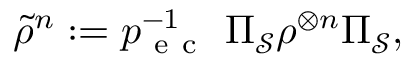<formula> <loc_0><loc_0><loc_500><loc_500>\tilde { \rho } ^ { n } \colon = p _ { e c } ^ { - 1 } \Pi _ { \mathcal { S } } \rho ^ { \otimes n } \Pi _ { \mathcal { S } } ,</formula> 